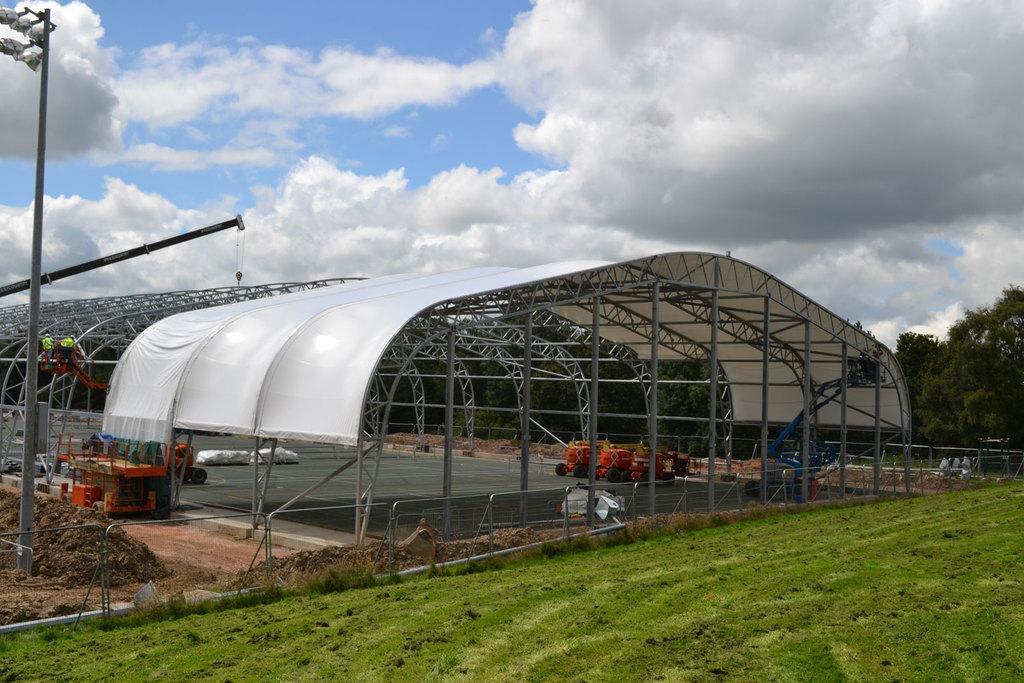Describe this image in one or two sentences. In this image, we can see a shed and there are rods and we can see vehicles and some other objects. In the background, there are trees, fences, poles and lights. At the bottom, there is sand and ground. At the top, there are clouds in the sky. 